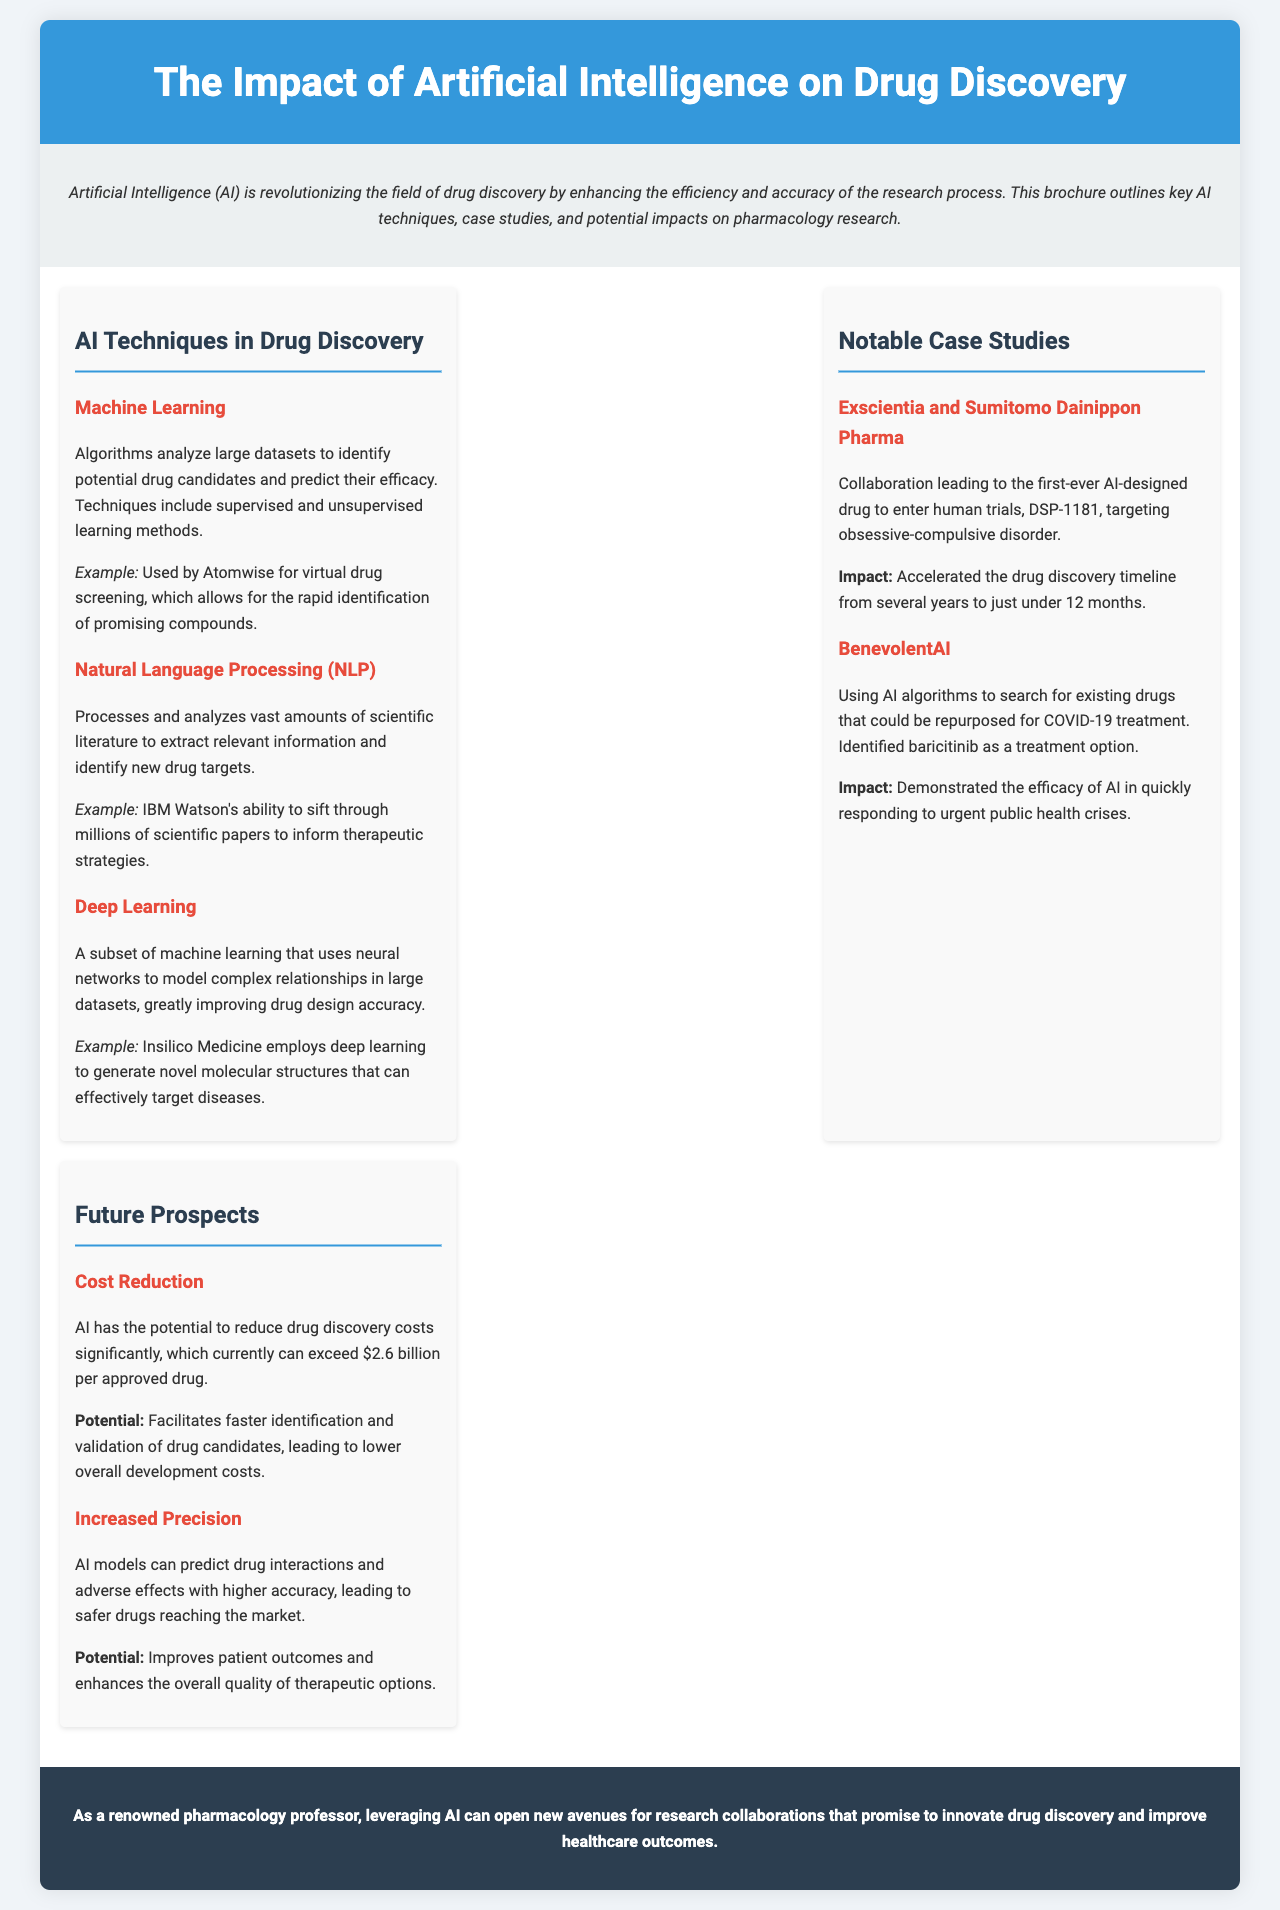What is the title of the brochure? The title is stated at the top of the document, which introduces the main theme of the content.
Answer: The Impact of Artificial Intelligence on Drug Discovery What are the primary AI techniques mentioned? The brochure lists AI techniques that are essential for drug discovery in a dedicated section.
Answer: Machine Learning, Natural Language Processing (NLP), Deep Learning Which company is associated with virtual drug screening? The brochure provides an example of a company using AI in drug discovery, located in the section on AI techniques.
Answer: Atomwise What drug did Exscientia and Sumitomo Dainippon Pharma develop? This information is presented in the case study section detailing the collaboration and its outcome.
Answer: DSP-1181 What is the potential cost reduction in drug discovery mentioned? The brochure highlights a significant financial figure concerning the costs involved in drug development.
Answer: $2.6 billion How quickly was DSP-1181 developed from inception to trials? This detail emphasizes the impact of AI on the drug discovery timeline highlighted in the case studies section.
Answer: Just under 12 months What is one potential benefit of increased precision in drug discovery? This question relates to the advantages of AI models discussed in the context of drug interactions and safety in the future prospects section.
Answer: Safer drugs What is the concluding statement's focus regarding research collaborations? The conclusion section emphasizes the potential benefits of leveraging AI in pharmacology research.
Answer: Innovate drug discovery and improve healthcare outcomes 